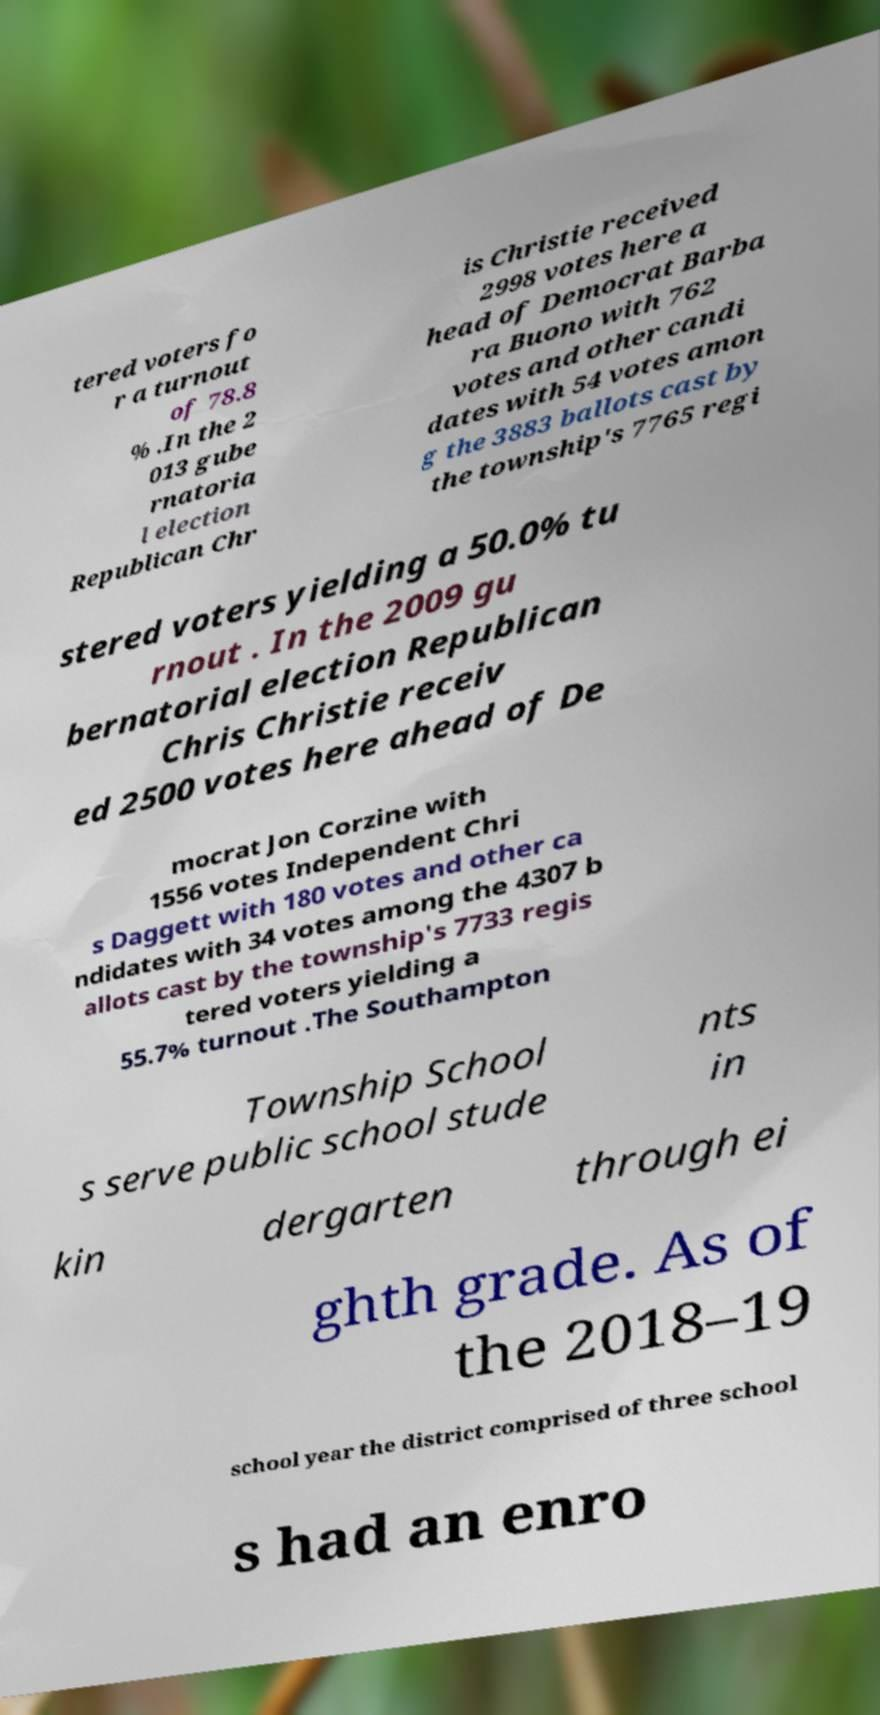What messages or text are displayed in this image? I need them in a readable, typed format. tered voters fo r a turnout of 78.8 % .In the 2 013 gube rnatoria l election Republican Chr is Christie received 2998 votes here a head of Democrat Barba ra Buono with 762 votes and other candi dates with 54 votes amon g the 3883 ballots cast by the township's 7765 regi stered voters yielding a 50.0% tu rnout . In the 2009 gu bernatorial election Republican Chris Christie receiv ed 2500 votes here ahead of De mocrat Jon Corzine with 1556 votes Independent Chri s Daggett with 180 votes and other ca ndidates with 34 votes among the 4307 b allots cast by the township's 7733 regis tered voters yielding a 55.7% turnout .The Southampton Township School s serve public school stude nts in kin dergarten through ei ghth grade. As of the 2018–19 school year the district comprised of three school s had an enro 